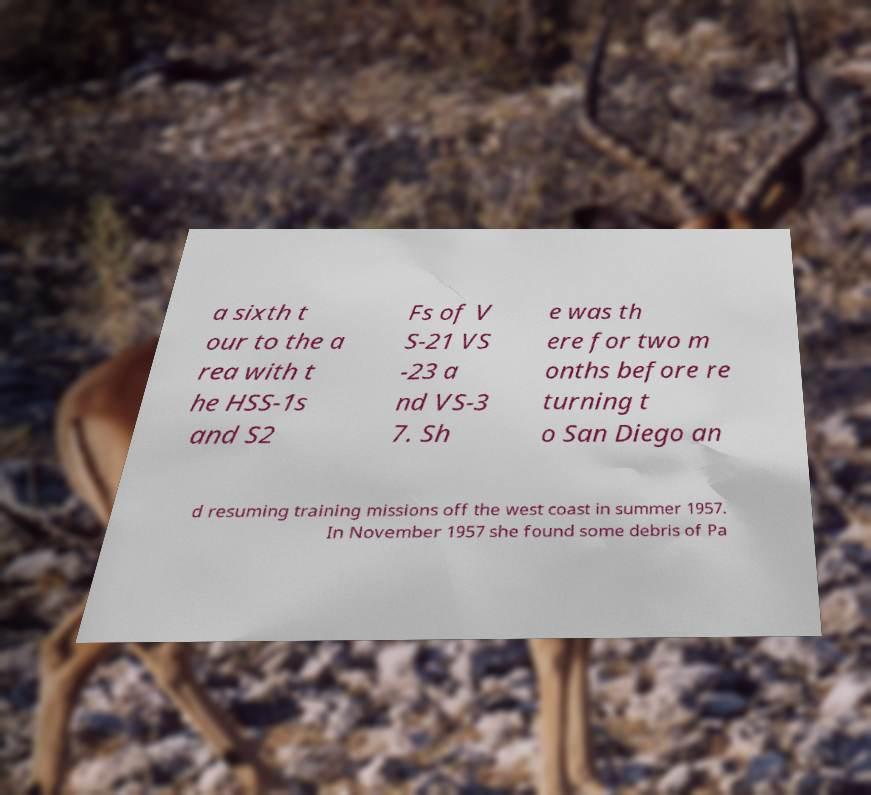Please read and relay the text visible in this image. What does it say? a sixth t our to the a rea with t he HSS-1s and S2 Fs of V S-21 VS -23 a nd VS-3 7. Sh e was th ere for two m onths before re turning t o San Diego an d resuming training missions off the west coast in summer 1957. In November 1957 she found some debris of Pa 